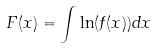<formula> <loc_0><loc_0><loc_500><loc_500>F ( x ) = \int \ln ( f ( x ) ) d x</formula> 